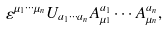<formula> <loc_0><loc_0><loc_500><loc_500>\varepsilon ^ { \mu _ { 1 } \cdots \mu _ { n } } U _ { a _ { 1 } \cdots a _ { n } } A ^ { a _ { 1 } } _ { \mu _ { 1 } } \cdots A ^ { a _ { n } } _ { \mu _ { n } } ,</formula> 